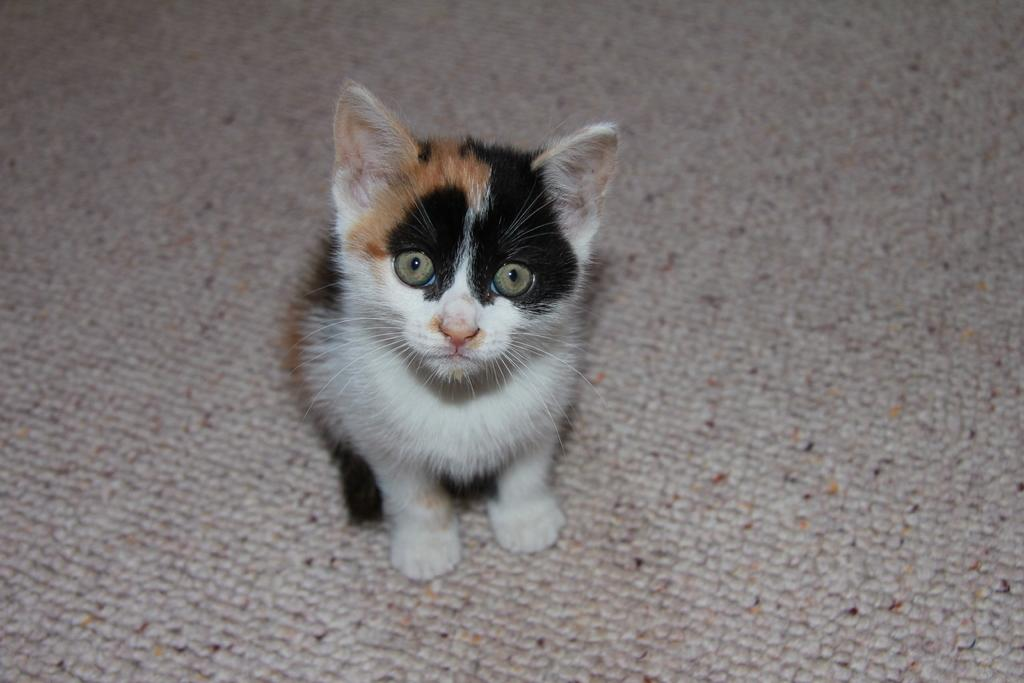What is the main subject in the center of the image? There is a cat in the center of the image. What is located at the bottom of the image? There is a carpet at the bottom of the image. What type of rice can be seen in the image? There is no rice present in the image; it features a cat and a carpet. How many potatoes are visible in the image? There are no potatoes present in the image. 